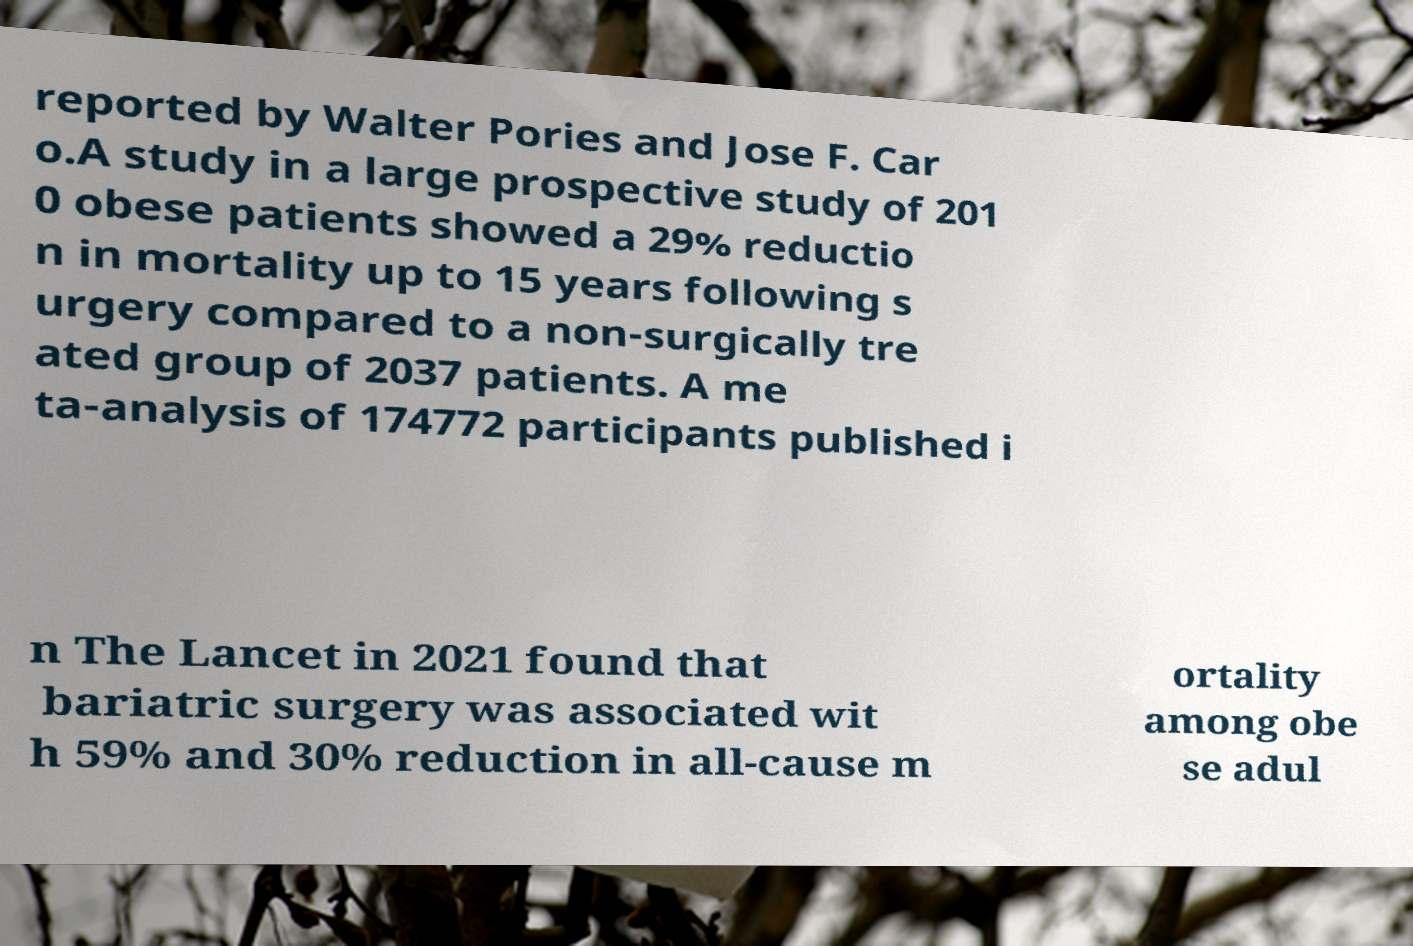Could you assist in decoding the text presented in this image and type it out clearly? reported by Walter Pories and Jose F. Car o.A study in a large prospective study of 201 0 obese patients showed a 29% reductio n in mortality up to 15 years following s urgery compared to a non-surgically tre ated group of 2037 patients. A me ta-analysis of 174772 participants published i n The Lancet in 2021 found that bariatric surgery was associated wit h 59% and 30% reduction in all-cause m ortality among obe se adul 